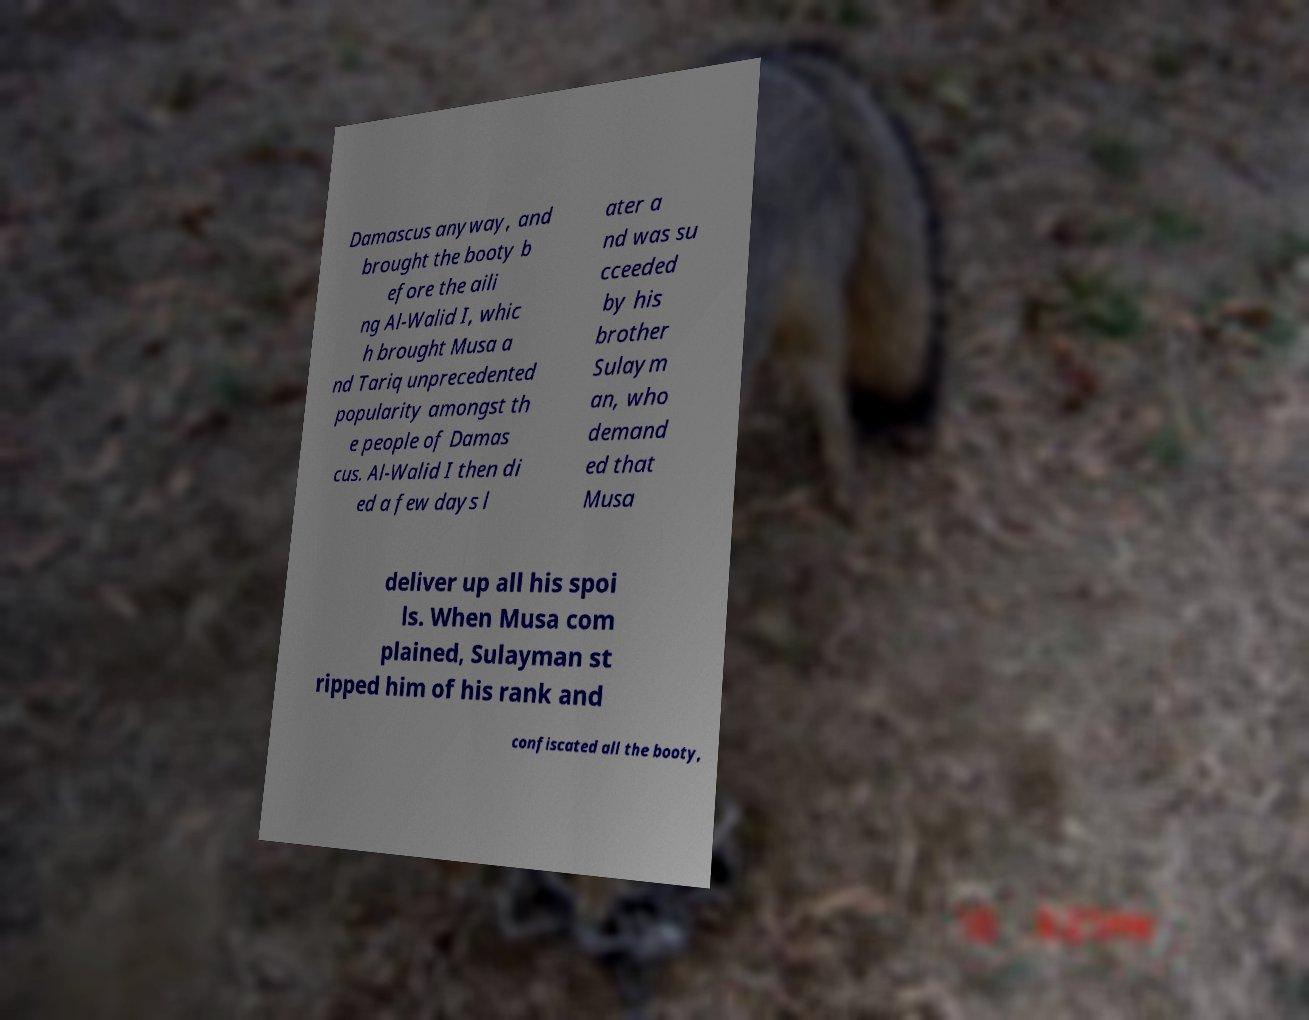Could you assist in decoding the text presented in this image and type it out clearly? Damascus anyway, and brought the booty b efore the aili ng Al-Walid I, whic h brought Musa a nd Tariq unprecedented popularity amongst th e people of Damas cus. Al-Walid I then di ed a few days l ater a nd was su cceeded by his brother Sulaym an, who demand ed that Musa deliver up all his spoi ls. When Musa com plained, Sulayman st ripped him of his rank and confiscated all the booty, 